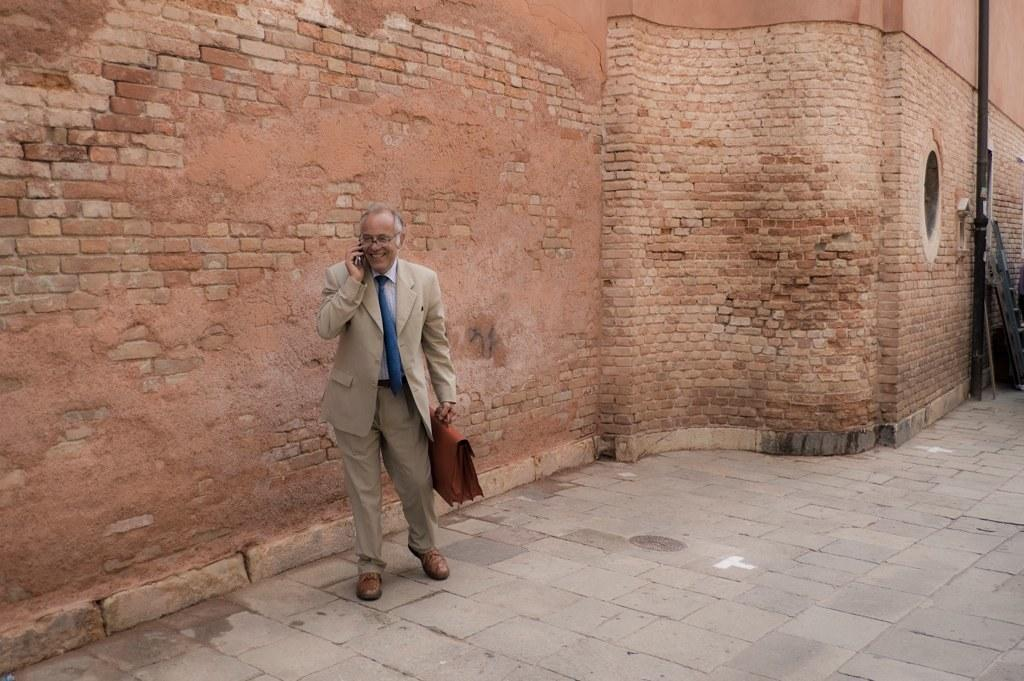What is the main subject of the image? There is a person in the image. What is the person doing in the image? The person is walking. What objects is the person holding in the image? The person is holding a mobile phone and a bag. What can be seen in the background of the image? There is a wall and a pole in the background of the image. What riddle is the person trying to solve while walking in the image? There is no riddle present in the image; the person is simply walking while holding a mobile phone and a bag. Can you see any magic or magical elements in the image? There are no magic or magical elements present in the image. 